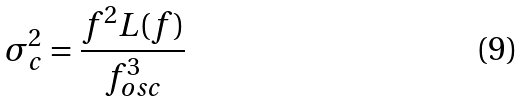<formula> <loc_0><loc_0><loc_500><loc_500>\sigma _ { c } ^ { 2 } = \frac { f ^ { 2 } L ( f ) } { f _ { o s c } ^ { 3 } }</formula> 